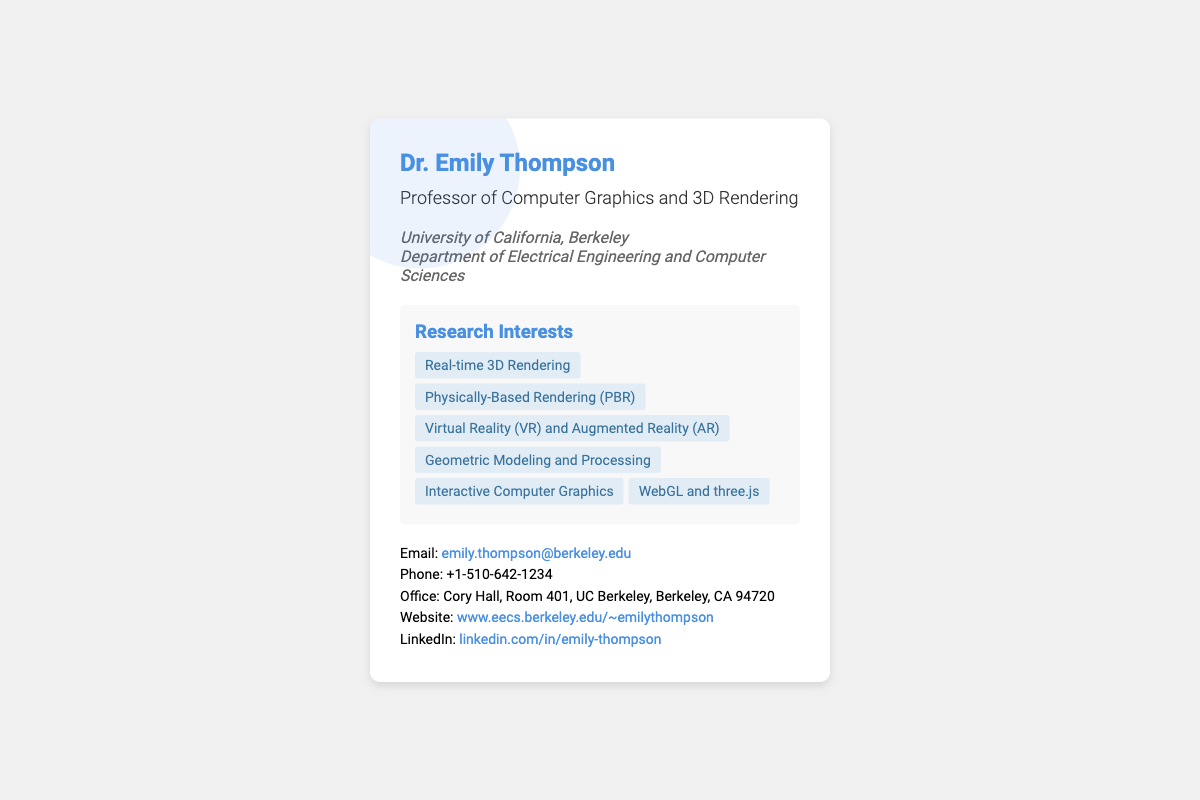What is the name of the professor? The name is clearly stated at the top of the business card.
Answer: Dr. Emily Thompson What university is Dr. Emily Thompson affiliated with? The document specifies the university in the introductory section.
Answer: University of California, Berkeley What is Dr. Thompson's email address? The email is mentioned in the contact section of the card.
Answer: emily.thompson@berkeley.edu How many research interests are listed? The number of items in the research interests section can be counted.
Answer: Six Which area related to computer graphics is NOT mentioned as a research interest? By analyzing the provided research interests, we can determine which areas are excluded.
Answer: Animation What is the office room number for Dr. Thompson? The specific office room number is provided in the contact details.
Answer: Room 401 What is the phone number provided on the business card? The document contains this specific information under the contact section.
Answer: +1-510-642-1234 What is the title held by Dr. Thompson? The title is indicated right below the name on the business card.
Answer: Professor of Computer Graphics and 3D Rendering 